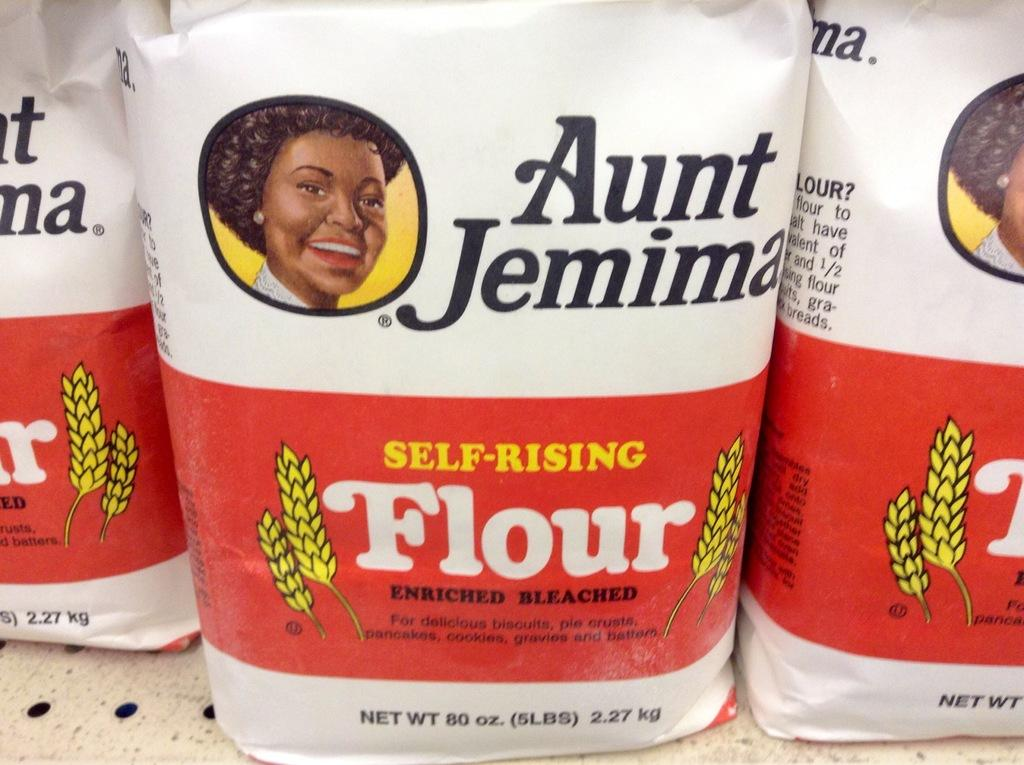What type of bags are visible in the image? There are flour bags in the image. Where are the flour bags located? The flour bags are placed on the floor. How many snakes are slithering around the flour bags in the image? There are no snakes present in the image; it only features flour bags placed on the floor. What type of vehicle is parked next to the flour bags in the image? There is no vehicle present in the image; it only features flour bags placed on the floor. 